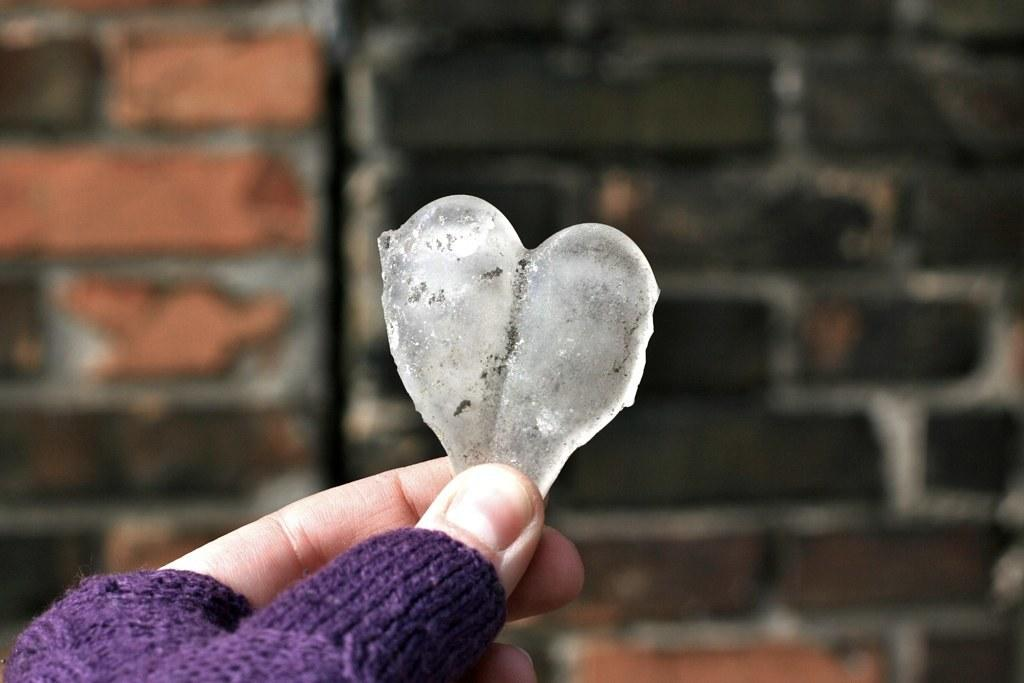What is the person's hand holding in the image? The person's hand is holding a stone in the image. What can be seen in the background of the image? There is a wall in the background of the image. How many actors are present in the image? There are no actors present in the image; it only shows a person's hand holding a stone and a wall in the background. 